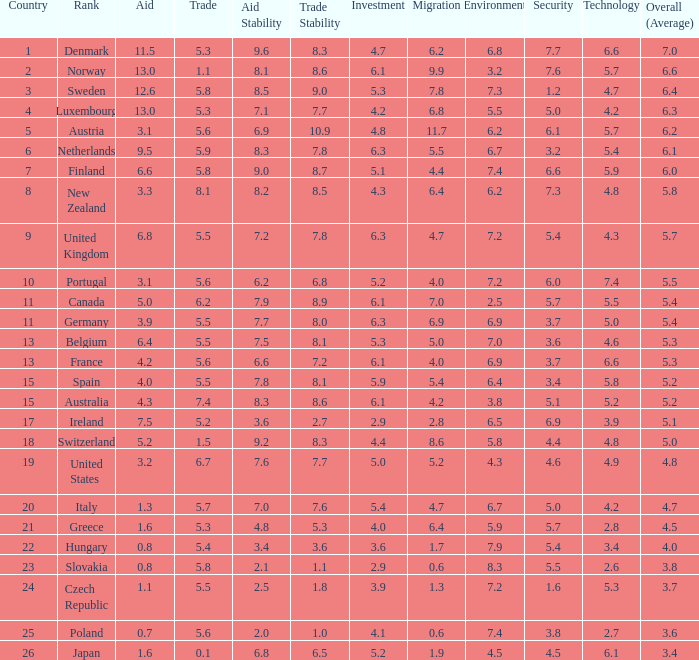What country has a 5.5 mark for security? Slovakia. 